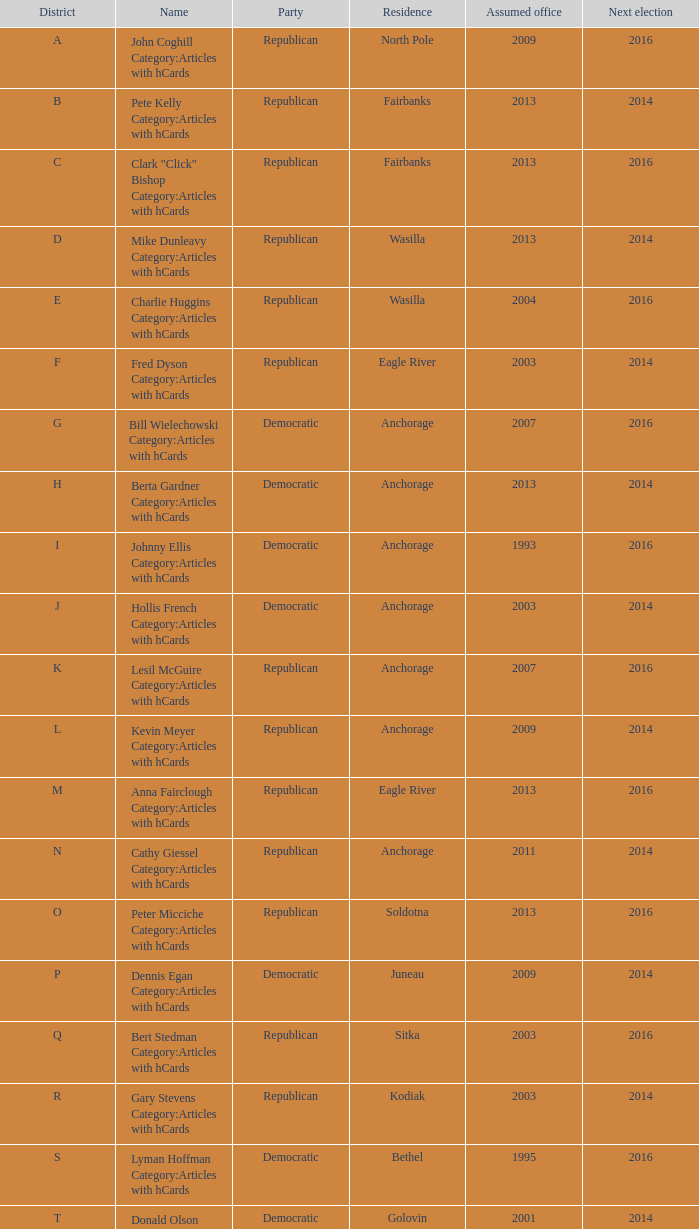What is the name of the Senator in the O District who assumed office in 2013? Peter Micciche Category:Articles with hCards. 